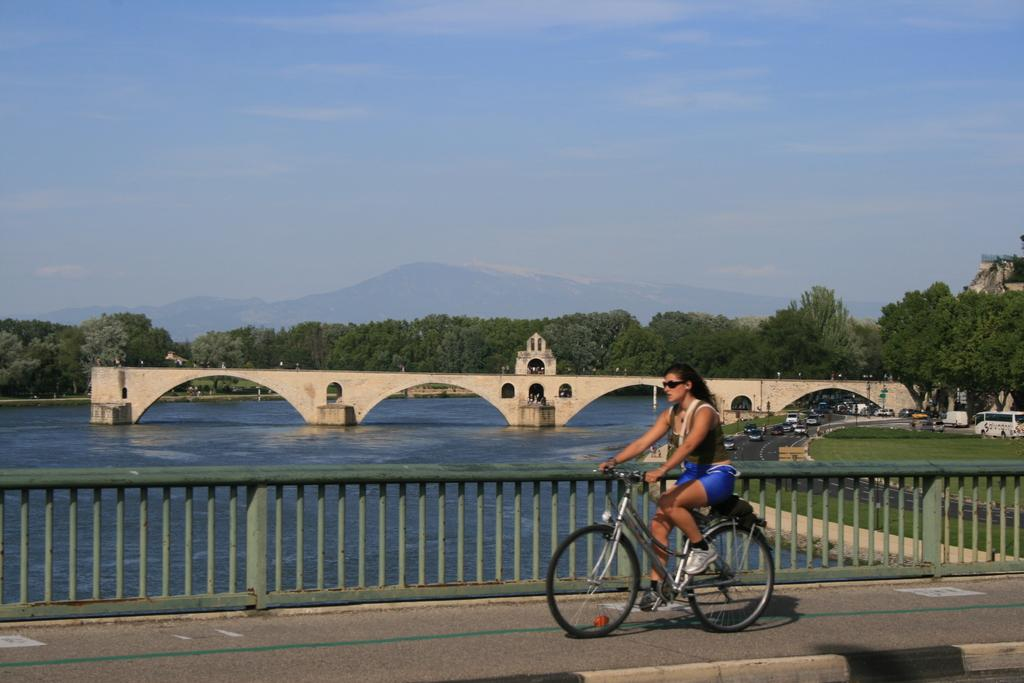What type of natural features can be seen in the distance in the image? There are trees and mountains in the distance in the image. What type of water body is present in the image? It is a freshwater river in the image. What structure is present over the river? There is a bridge in the image. What mode of transportation is being used by a person in the image? A woman is riding a bicycle in the image. What type of barrier is present in the image? There is a fence in the image. What type of government is depicted in the image? There is no depiction of a government in the image; it features natural scenery, a river, a bridge, and a woman riding a bicycle. Can you tell me how many quartz rocks are present in the image? There are no quartz rocks visible in the image. 